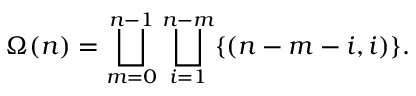<formula> <loc_0><loc_0><loc_500><loc_500>\Omega ( n ) = \bigsqcup _ { m = 0 } ^ { n - 1 } \bigsqcup _ { i = 1 } ^ { n - m } \{ ( n - m - i , i ) \} .</formula> 